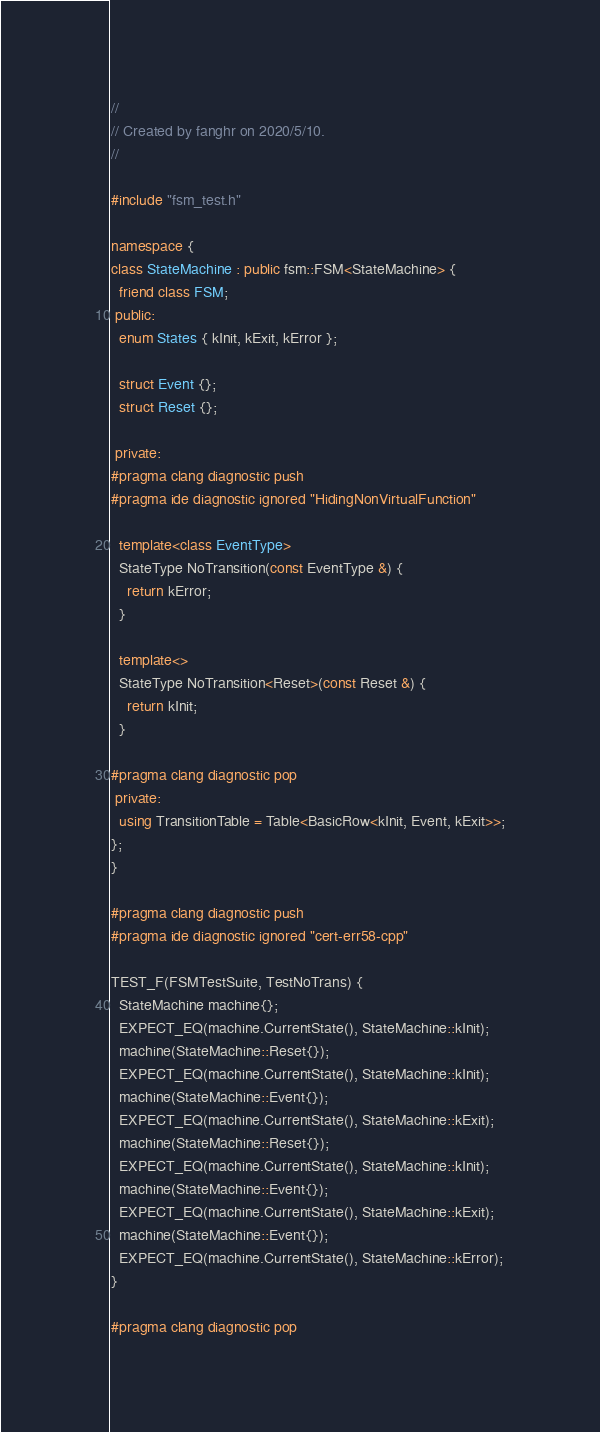<code> <loc_0><loc_0><loc_500><loc_500><_C++_>
//
// Created by fanghr on 2020/5/10.
//

#include "fsm_test.h"

namespace {
class StateMachine : public fsm::FSM<StateMachine> {
  friend class FSM;
 public:
  enum States { kInit, kExit, kError };

  struct Event {};
  struct Reset {};

 private:
#pragma clang diagnostic push
#pragma ide diagnostic ignored "HidingNonVirtualFunction"

  template<class EventType>
  StateType NoTransition(const EventType &) {
    return kError;
  }

  template<>
  StateType NoTransition<Reset>(const Reset &) {
    return kInit;
  }

#pragma clang diagnostic pop
 private:
  using TransitionTable = Table<BasicRow<kInit, Event, kExit>>;
};
}

#pragma clang diagnostic push
#pragma ide diagnostic ignored "cert-err58-cpp"

TEST_F(FSMTestSuite, TestNoTrans) {
  StateMachine machine{};
  EXPECT_EQ(machine.CurrentState(), StateMachine::kInit);
  machine(StateMachine::Reset{});
  EXPECT_EQ(machine.CurrentState(), StateMachine::kInit);
  machine(StateMachine::Event{});
  EXPECT_EQ(machine.CurrentState(), StateMachine::kExit);
  machine(StateMachine::Reset{});
  EXPECT_EQ(machine.CurrentState(), StateMachine::kInit);
  machine(StateMachine::Event{});
  EXPECT_EQ(machine.CurrentState(), StateMachine::kExit);
  machine(StateMachine::Event{});
  EXPECT_EQ(machine.CurrentState(), StateMachine::kError);
}

#pragma clang diagnostic pop</code> 